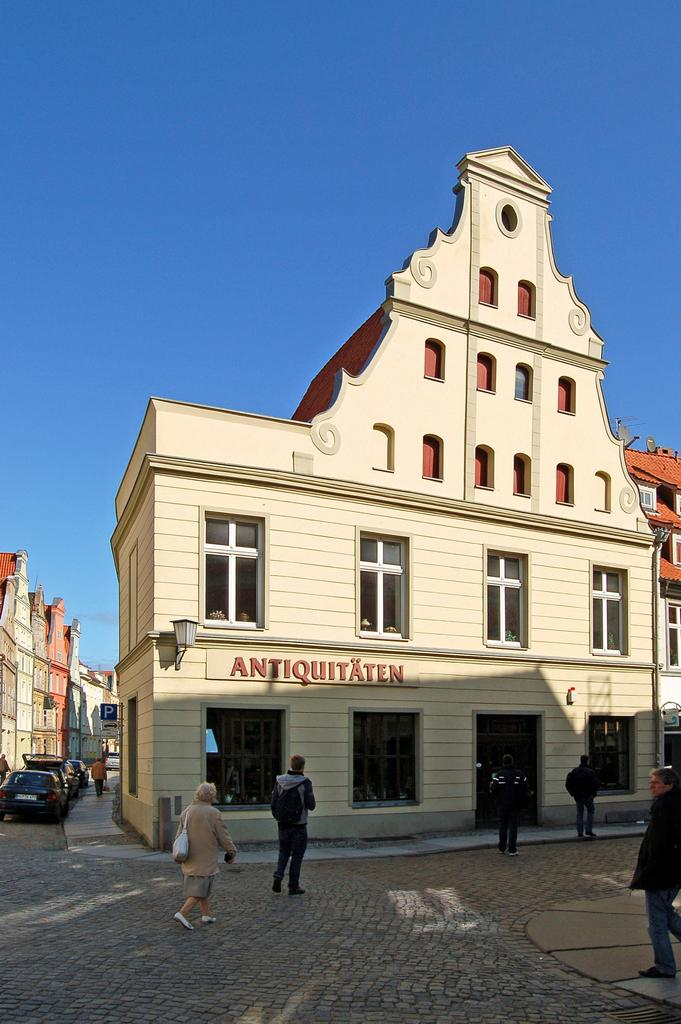<image>
Relay a brief, clear account of the picture shown. a store called antiquitaten is housed in a lovely white building 